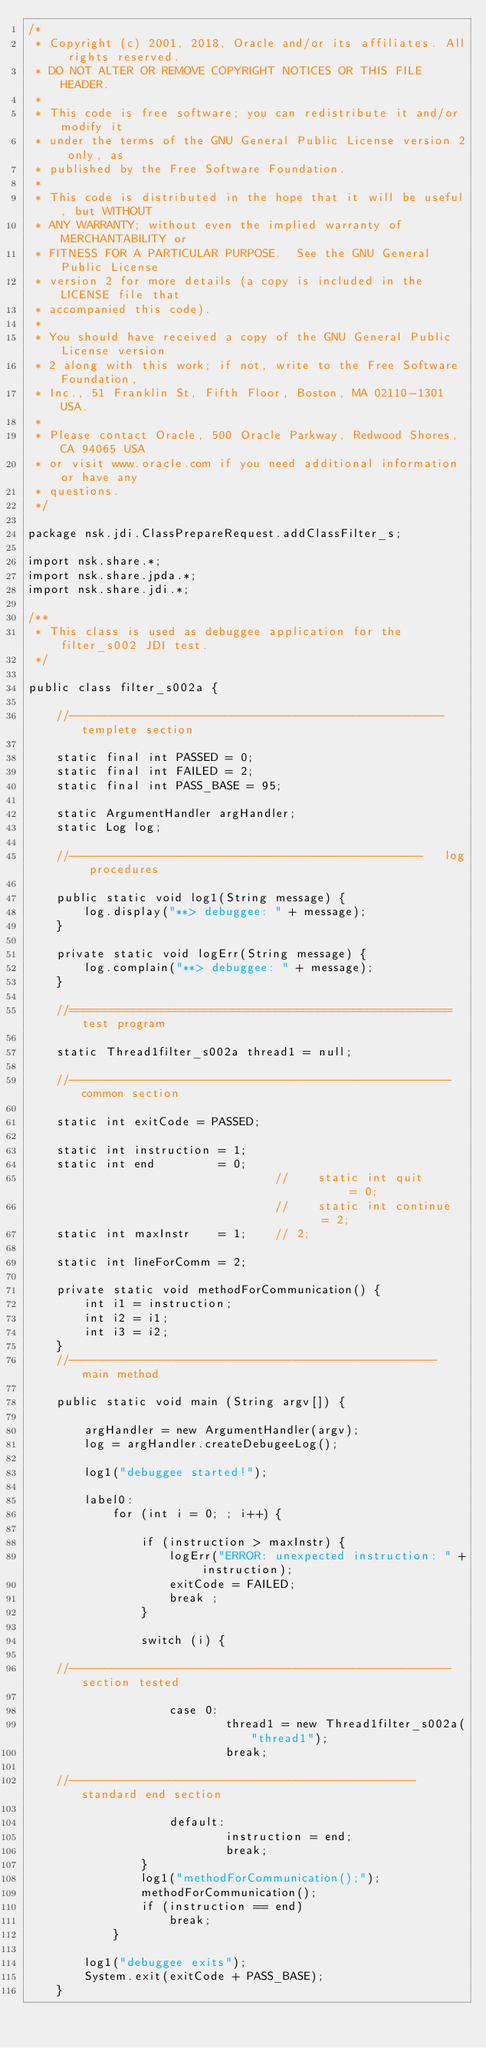Convert code to text. <code><loc_0><loc_0><loc_500><loc_500><_Java_>/*
 * Copyright (c) 2001, 2018, Oracle and/or its affiliates. All rights reserved.
 * DO NOT ALTER OR REMOVE COPYRIGHT NOTICES OR THIS FILE HEADER.
 *
 * This code is free software; you can redistribute it and/or modify it
 * under the terms of the GNU General Public License version 2 only, as
 * published by the Free Software Foundation.
 *
 * This code is distributed in the hope that it will be useful, but WITHOUT
 * ANY WARRANTY; without even the implied warranty of MERCHANTABILITY or
 * FITNESS FOR A PARTICULAR PURPOSE.  See the GNU General Public License
 * version 2 for more details (a copy is included in the LICENSE file that
 * accompanied this code).
 *
 * You should have received a copy of the GNU General Public License version
 * 2 along with this work; if not, write to the Free Software Foundation,
 * Inc., 51 Franklin St, Fifth Floor, Boston, MA 02110-1301 USA.
 *
 * Please contact Oracle, 500 Oracle Parkway, Redwood Shores, CA 94065 USA
 * or visit www.oracle.com if you need additional information or have any
 * questions.
 */

package nsk.jdi.ClassPrepareRequest.addClassFilter_s;

import nsk.share.*;
import nsk.share.jpda.*;
import nsk.share.jdi.*;

/**
 * This class is used as debuggee application for the filter_s002 JDI test.
 */

public class filter_s002a {

    //----------------------------------------------------- templete section

    static final int PASSED = 0;
    static final int FAILED = 2;
    static final int PASS_BASE = 95;

    static ArgumentHandler argHandler;
    static Log log;

    //--------------------------------------------------   log procedures

    public static void log1(String message) {
        log.display("**> debuggee: " + message);
    }

    private static void logErr(String message) {
        log.complain("**> debuggee: " + message);
    }

    //====================================================== test program

    static Thread1filter_s002a thread1 = null;

    //------------------------------------------------------ common section

    static int exitCode = PASSED;

    static int instruction = 1;
    static int end         = 0;
                                   //    static int quit        = 0;
                                   //    static int continue    = 2;
    static int maxInstr    = 1;    // 2;

    static int lineForComm = 2;

    private static void methodForCommunication() {
        int i1 = instruction;
        int i2 = i1;
        int i3 = i2;
    }
    //----------------------------------------------------   main method

    public static void main (String argv[]) {

        argHandler = new ArgumentHandler(argv);
        log = argHandler.createDebugeeLog();

        log1("debuggee started!");

        label0:
            for (int i = 0; ; i++) {

                if (instruction > maxInstr) {
                    logErr("ERROR: unexpected instruction: " + instruction);
                    exitCode = FAILED;
                    break ;
                }

                switch (i) {

    //------------------------------------------------------  section tested

                    case 0:
                            thread1 = new Thread1filter_s002a("thread1");
                            break;

    //-------------------------------------------------    standard end section

                    default:
                            instruction = end;
                            break;
                }
                log1("methodForCommunication();");
                methodForCommunication();
                if (instruction == end)
                    break;
            }

        log1("debuggee exits");
        System.exit(exitCode + PASS_BASE);
    }
</code> 